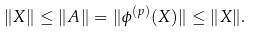<formula> <loc_0><loc_0><loc_500><loc_500>\| X \| \leq \| A \| = \| \phi ^ { ( p ) } ( X ) \| \leq \| X \| .</formula> 